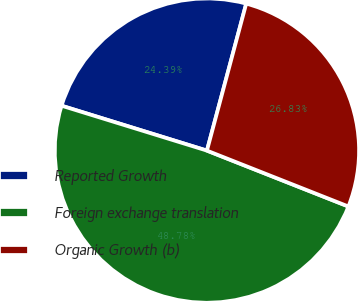Convert chart. <chart><loc_0><loc_0><loc_500><loc_500><pie_chart><fcel>Reported Growth<fcel>Foreign exchange translation<fcel>Organic Growth (b)<nl><fcel>24.39%<fcel>48.78%<fcel>26.83%<nl></chart> 